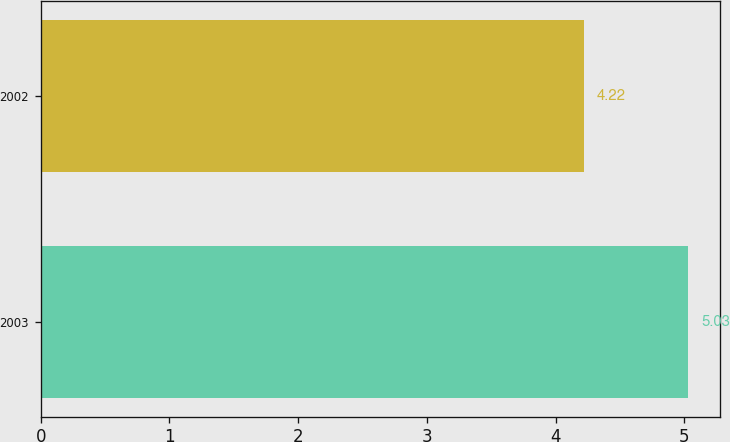<chart> <loc_0><loc_0><loc_500><loc_500><bar_chart><fcel>2003<fcel>2002<nl><fcel>5.03<fcel>4.22<nl></chart> 